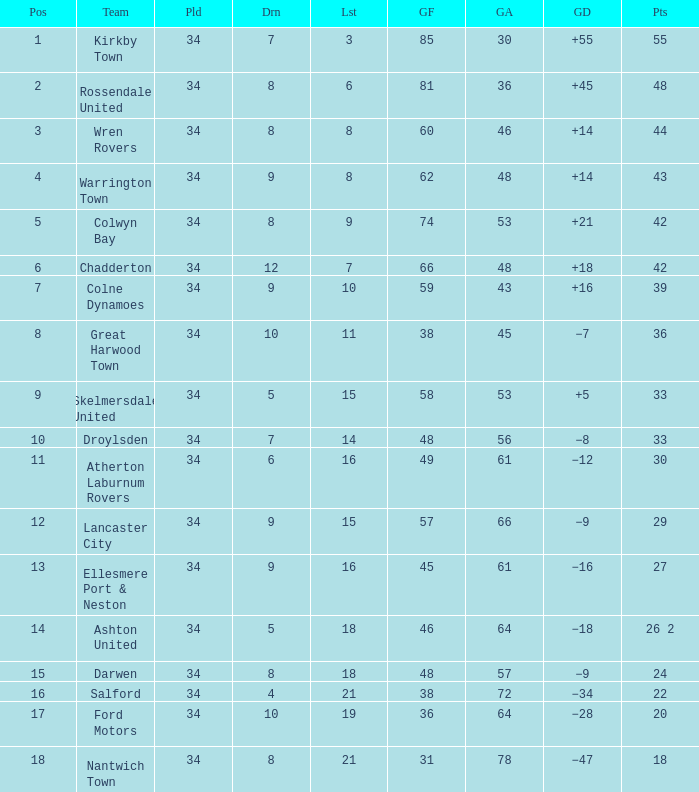What is the smallest number of goals against when there are 1 of 18 points, and more than 8 are drawn? None. 